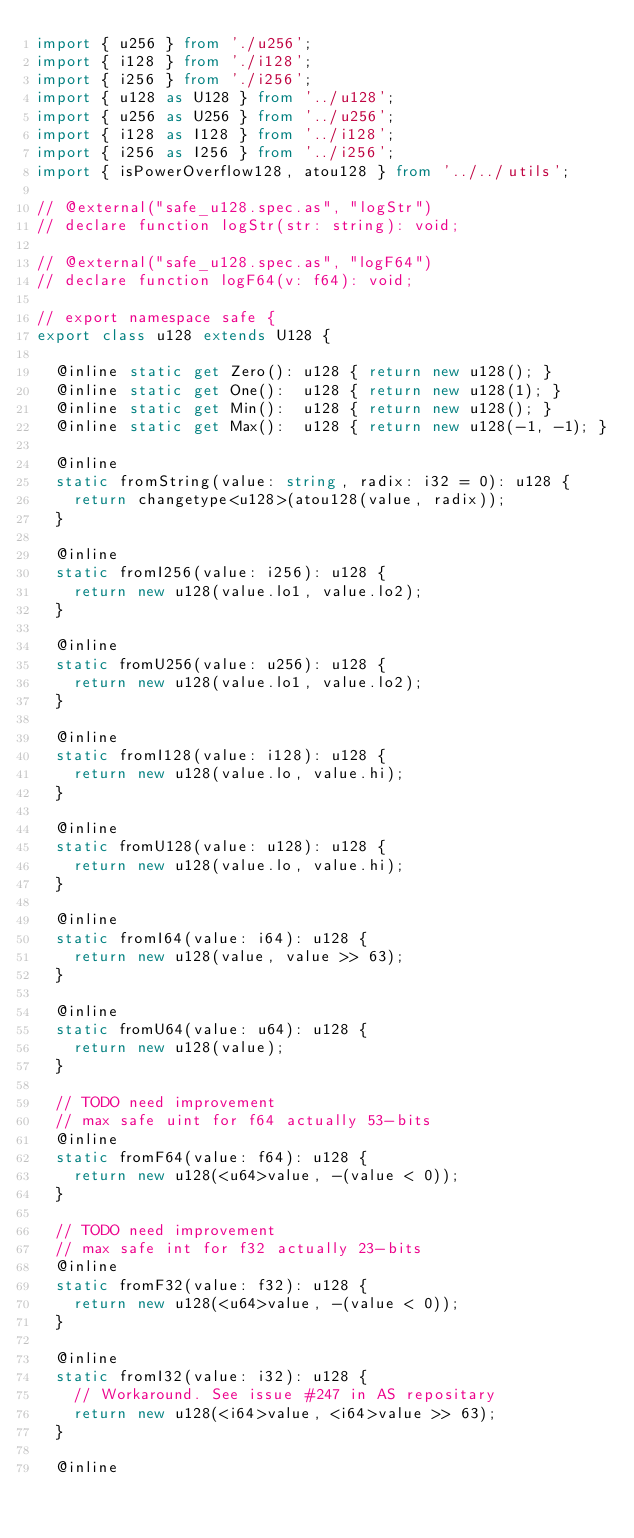<code> <loc_0><loc_0><loc_500><loc_500><_TypeScript_>import { u256 } from './u256';
import { i128 } from './i128';
import { i256 } from './i256';
import { u128 as U128 } from '../u128';
import { u256 as U256 } from '../u256';
import { i128 as I128 } from '../i128';
import { i256 as I256 } from '../i256';
import { isPowerOverflow128, atou128 } from '../../utils';

// @external("safe_u128.spec.as", "logStr")
// declare function logStr(str: string): void;

// @external("safe_u128.spec.as", "logF64")
// declare function logF64(v: f64): void;

// export namespace safe {
export class u128 extends U128 {

  @inline static get Zero(): u128 { return new u128(); }
  @inline static get One():  u128 { return new u128(1); }
  @inline static get Min():  u128 { return new u128(); }
  @inline static get Max():  u128 { return new u128(-1, -1); }

  @inline
  static fromString(value: string, radix: i32 = 0): u128 {
    return changetype<u128>(atou128(value, radix));
  }

  @inline
  static fromI256(value: i256): u128 {
    return new u128(value.lo1, value.lo2);
  }

  @inline
  static fromU256(value: u256): u128 {
    return new u128(value.lo1, value.lo2);
  }

  @inline
  static fromI128(value: i128): u128 {
    return new u128(value.lo, value.hi);
  }

  @inline
  static fromU128(value: u128): u128 {
    return new u128(value.lo, value.hi);
  }

  @inline
  static fromI64(value: i64): u128 {
    return new u128(value, value >> 63);
  }

  @inline
  static fromU64(value: u64): u128 {
    return new u128(value);
  }

  // TODO need improvement
  // max safe uint for f64 actually 53-bits
  @inline
  static fromF64(value: f64): u128 {
    return new u128(<u64>value, -(value < 0));
  }

  // TODO need improvement
  // max safe int for f32 actually 23-bits
  @inline
  static fromF32(value: f32): u128 {
    return new u128(<u64>value, -(value < 0));
  }

  @inline
  static fromI32(value: i32): u128 {
    // Workaround. See issue #247 in AS repositary
    return new u128(<i64>value, <i64>value >> 63);
  }

  @inline</code> 